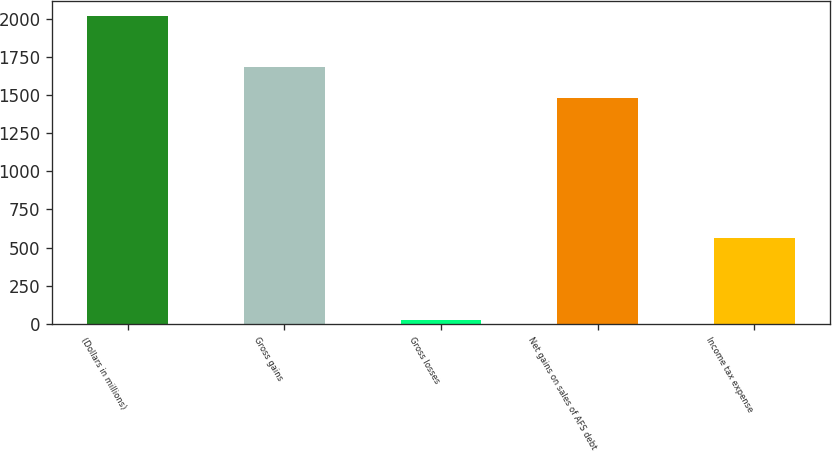Convert chart. <chart><loc_0><loc_0><loc_500><loc_500><bar_chart><fcel>(Dollars in millions)<fcel>Gross gains<fcel>Gross losses<fcel>Net gains on sales of AFS debt<fcel>Income tax expense<nl><fcel>2014<fcel>1680.1<fcel>23<fcel>1481<fcel>563<nl></chart> 